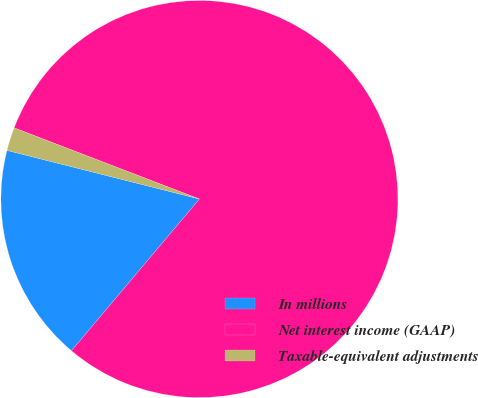Convert chart to OTSL. <chart><loc_0><loc_0><loc_500><loc_500><pie_chart><fcel>In millions<fcel>Net interest income (GAAP)<fcel>Taxable-equivalent adjustments<nl><fcel>17.79%<fcel>80.32%<fcel>1.9%<nl></chart> 